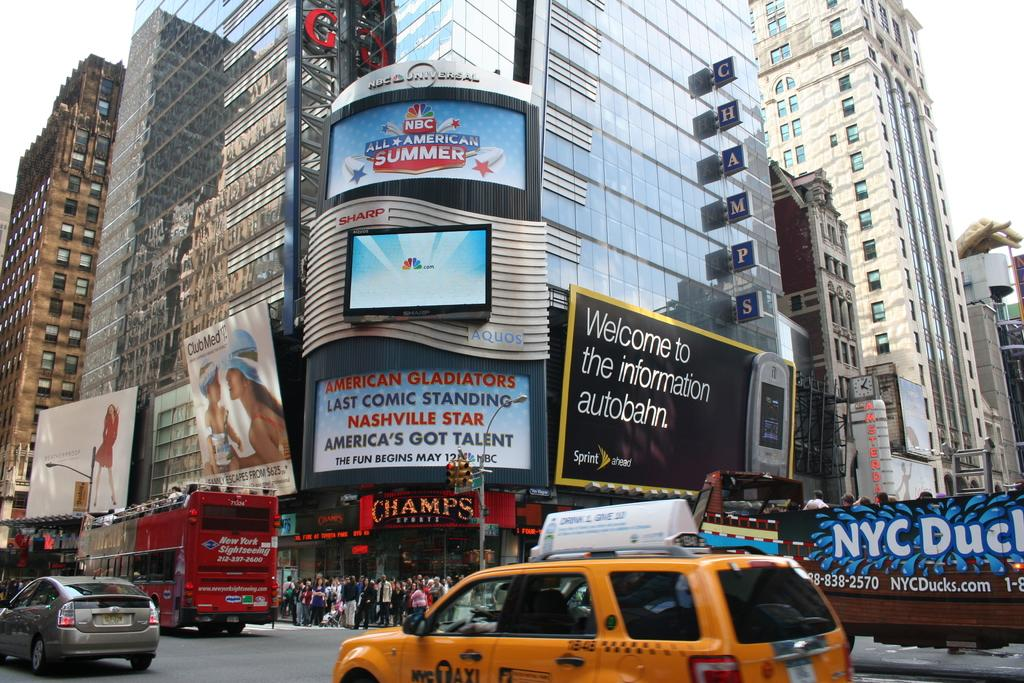<image>
Write a terse but informative summary of the picture. A black billboard says "welcome to the information autobahn." 